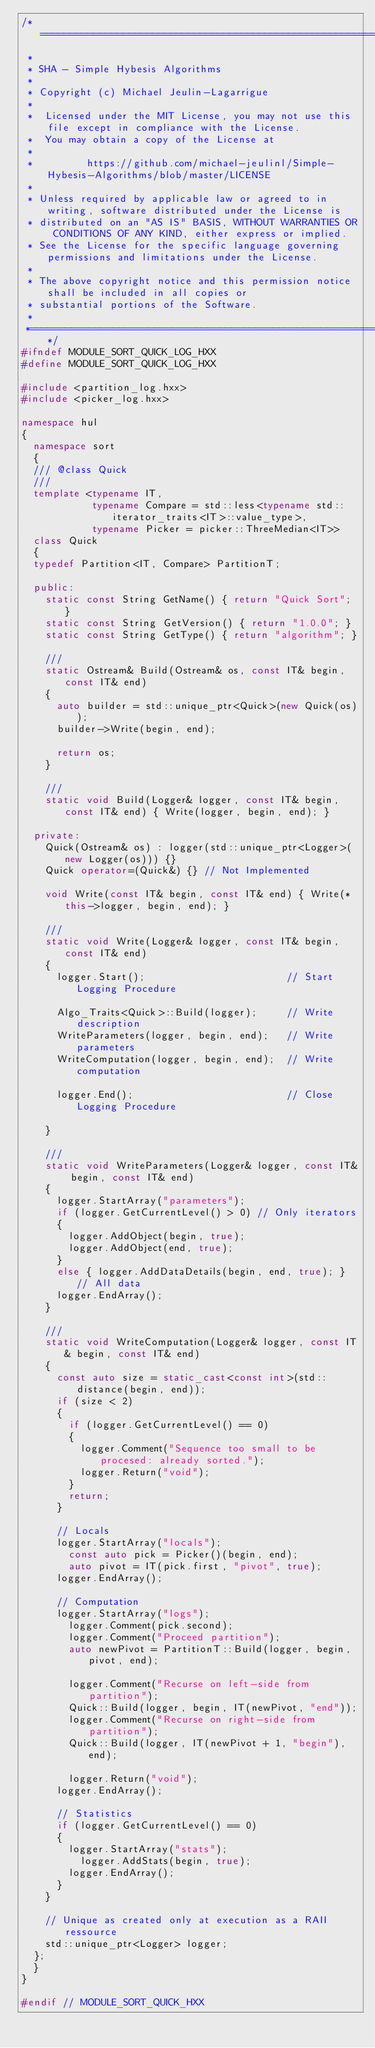Convert code to text. <code><loc_0><loc_0><loc_500><loc_500><_C++_>/*===========================================================================================================
 *
 * SHA - Simple Hybesis Algorithms
 *
 * Copyright (c) Michael Jeulin-Lagarrigue
 *
 *  Licensed under the MIT License, you may not use this file except in compliance with the License.
 *  You may obtain a copy of the License at
 *
 *         https://github.com/michael-jeulinl/Simple-Hybesis-Algorithms/blob/master/LICENSE
 *
 * Unless required by applicable law or agreed to in writing, software distributed under the License is
 * distributed on an "AS IS" BASIS, WITHOUT WARRANTIES OR CONDITIONS OF ANY KIND, either express or implied.
 * See the License for the specific language governing permissions and limitations under the License.
 *
 * The above copyright notice and this permission notice shall be included in all copies or
 * substantial portions of the Software.
 *
 *=========================================================================================================*/
#ifndef MODULE_SORT_QUICK_LOG_HXX
#define MODULE_SORT_QUICK_LOG_HXX

#include <partition_log.hxx>
#include <picker_log.hxx>

namespace hul
{
  namespace sort
  {
  /// @class Quick
  ///
  template <typename IT,
            typename Compare = std::less<typename std::iterator_traits<IT>::value_type>,
            typename Picker = picker::ThreeMedian<IT>>
  class Quick
  {
  typedef Partition<IT, Compare> PartitionT;

  public:
    static const String GetName() { return "Quick Sort"; }
    static const String GetVersion() { return "1.0.0"; }
    static const String GetType() { return "algorithm"; }

    ///
    static Ostream& Build(Ostream& os, const IT& begin, const IT& end)
    {
      auto builder = std::unique_ptr<Quick>(new Quick(os));
      builder->Write(begin, end);

      return os;
    }

    ///
    static void Build(Logger& logger, const IT& begin, const IT& end) { Write(logger, begin, end); }

  private:
    Quick(Ostream& os) : logger(std::unique_ptr<Logger>(new Logger(os))) {}
    Quick operator=(Quick&) {} // Not Implemented

    void Write(const IT& begin, const IT& end) { Write(*this->logger, begin, end); }

    ///
    static void Write(Logger& logger, const IT& begin, const IT& end)
    {
      logger.Start();                        // Start Logging Procedure

      Algo_Traits<Quick>::Build(logger);     // Write description
      WriteParameters(logger, begin, end);   // Write parameters
      WriteComputation(logger, begin, end);  // Write computation

      logger.End();                          // Close Logging Procedure

    }

    ///
    static void WriteParameters(Logger& logger, const IT& begin, const IT& end)
    {
      logger.StartArray("parameters");
      if (logger.GetCurrentLevel() > 0) // Only iterators
      {
        logger.AddObject(begin, true);
        logger.AddObject(end, true);
      }
      else { logger.AddDataDetails(begin, end, true); } // All data
      logger.EndArray();
    }

    ///
    static void WriteComputation(Logger& logger, const IT& begin, const IT& end)
    {
      const auto size = static_cast<const int>(std::distance(begin, end));
      if (size < 2)
      {
        if (logger.GetCurrentLevel() == 0)
        {
          logger.Comment("Sequence too small to be procesed: already sorted.");
          logger.Return("void");
        }
        return;
      }

      // Locals
      logger.StartArray("locals");
        const auto pick = Picker()(begin, end);
        auto pivot = IT(pick.first, "pivot", true);
      logger.EndArray();

      // Computation
      logger.StartArray("logs");
        logger.Comment(pick.second);
        logger.Comment("Proceed partition");
        auto newPivot = PartitionT::Build(logger, begin, pivot, end);

        logger.Comment("Recurse on left-side from partition");
        Quick::Build(logger, begin, IT(newPivot, "end"));
        logger.Comment("Recurse on right-side from partition");
        Quick::Build(logger, IT(newPivot + 1, "begin"), end);

        logger.Return("void");
      logger.EndArray();

      // Statistics
      if (logger.GetCurrentLevel() == 0)
      {
        logger.StartArray("stats");
          logger.AddStats(begin, true);
        logger.EndArray();
      }
    }

    // Unique as created only at execution as a RAII ressource
    std::unique_ptr<Logger> logger;
  };
  }
}

#endif // MODULE_SORT_QUICK_HXX
</code> 